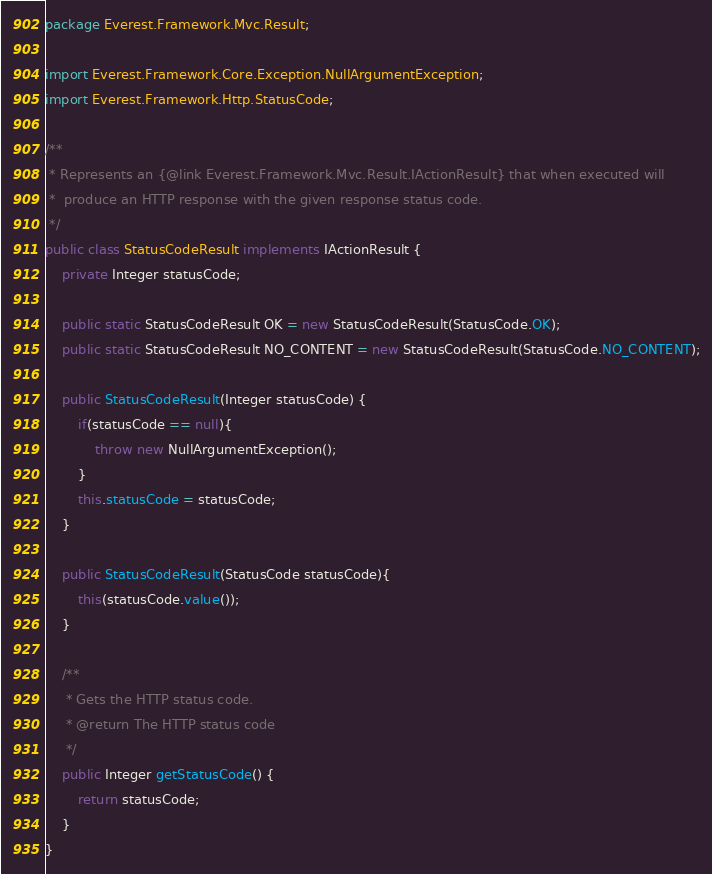<code> <loc_0><loc_0><loc_500><loc_500><_Java_>package Everest.Framework.Mvc.Result;

import Everest.Framework.Core.Exception.NullArgumentException;
import Everest.Framework.Http.StatusCode;

/**
 * Represents an {@link Everest.Framework.Mvc.Result.IActionResult} that when executed will
 *  produce an HTTP response with the given response status code.
 */
public class StatusCodeResult implements IActionResult {
    private Integer statusCode;

    public static StatusCodeResult OK = new StatusCodeResult(StatusCode.OK);
    public static StatusCodeResult NO_CONTENT = new StatusCodeResult(StatusCode.NO_CONTENT);

    public StatusCodeResult(Integer statusCode) {
        if(statusCode == null){
            throw new NullArgumentException();
        }
        this.statusCode = statusCode;
    }

    public StatusCodeResult(StatusCode statusCode){
        this(statusCode.value());
    }

    /**
     * Gets the HTTP status code.
     * @return The HTTP status code
     */
    public Integer getStatusCode() {
        return statusCode;
    }
}
</code> 